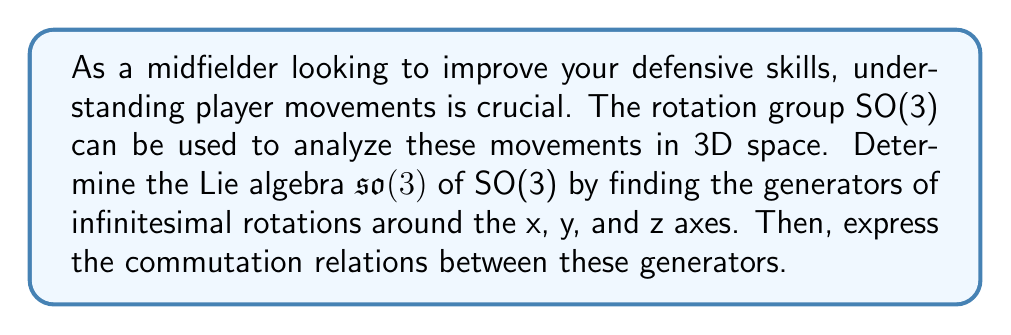Help me with this question. To determine the Lie algebra $\mathfrak{so}(3)$ of the rotation group SO(3), we need to follow these steps:

1) First, recall that SO(3) consists of 3x3 orthogonal matrices with determinant 1. The Lie algebra $\mathfrak{so}(3)$ consists of 3x3 skew-symmetric matrices.

2) The generators of infinitesimal rotations around the x, y, and z axes are:

   $$J_x = \begin{pmatrix}
   0 & 0 & 0 \\
   0 & 0 & -1 \\
   0 & 1 & 0
   \end{pmatrix}, \quad
   J_y = \begin{pmatrix}
   0 & 0 & 1 \\
   0 & 0 & 0 \\
   -1 & 0 & 0
   \end{pmatrix}, \quad
   J_z = \begin{pmatrix}
   0 & -1 & 0 \\
   1 & 0 & 0 \\
   0 & 0 & 0
   \end{pmatrix}$$

3) These matrices form a basis for $\mathfrak{so}(3)$. Any element of $\mathfrak{so}(3)$ can be written as a linear combination of these generators.

4) To express the commutation relations, we need to compute the Lie brackets $[J_i, J_j]$ for $i,j \in \{x,y,z\}$. The Lie bracket is defined as $[A,B] = AB - BA$.

5) Computing the commutators:

   $[J_x, J_y] = J_xJ_y - J_yJ_x = J_z$
   $[J_y, J_z] = J_yJ_z - J_zJ_y = J_x$
   $[J_z, J_x] = J_zJ_x - J_xJ_z = J_y$

6) These commutation relations can be summarized as:

   $$[J_i, J_j] = \epsilon_{ijk}J_k$$

   where $\epsilon_{ijk}$ is the Levi-Civita symbol.

This structure of $\mathfrak{so}(3)$ is crucial for understanding rotations in 3D space, which directly applies to analyzing player movements on the field.
Answer: The Lie algebra $\mathfrak{so}(3)$ of SO(3) is generated by the matrices $J_x$, $J_y$, and $J_z$ representing infinitesimal rotations around the x, y, and z axes respectively. The commutation relations between these generators are given by $[J_i, J_j] = \epsilon_{ijk}J_k$, where $\epsilon_{ijk}$ is the Levi-Civita symbol. 